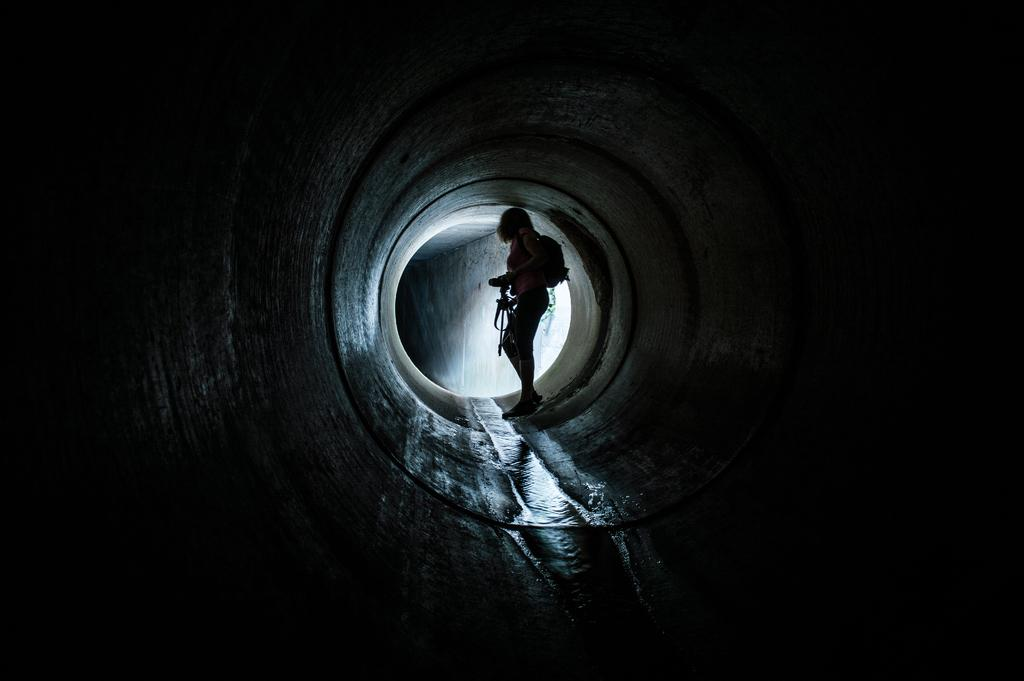What is the person in the image doing? The human in the image is standing and holding a camera in their hand. What else can be seen on the person in the image? The human has a backpack on their back. What can be seen in the background of the image? There is water visible in the image. What type of note is the cub holding in the image? There is no cub or note present in the image. 